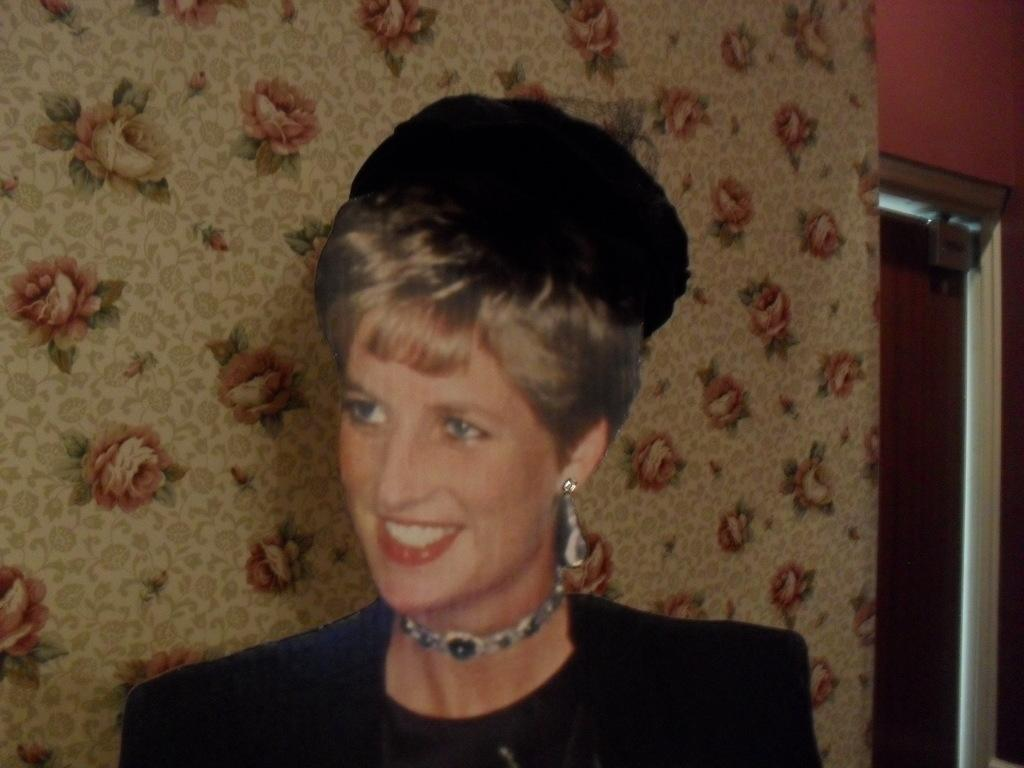Who is present in the image? There is a woman in the image. What is the woman wearing on her head? The woman is wearing a black cap. What type of accessory is the woman wearing? The woman is wearing a chain. What color is the jacket the woman is wearing? The woman is wearing a black jacket. What can be seen in the background of the image? There is a door in the image, and the wall is designed with flowers. What is the color of the door? The door is brown in color. What type of needle is the woman using to stop the door from closing in the image? There is no needle or indication of the door closing in the image. The woman is not using any tool to interact with the door. 